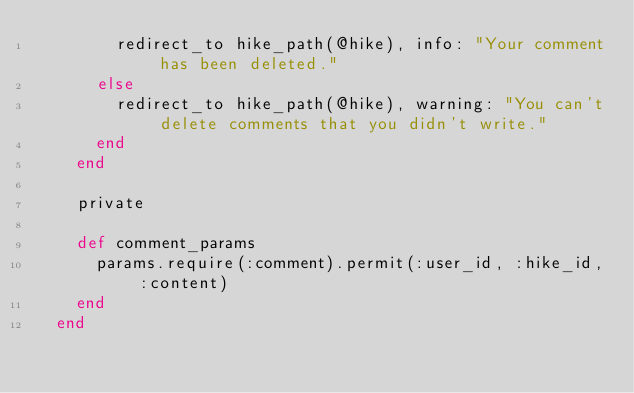<code> <loc_0><loc_0><loc_500><loc_500><_Ruby_>        redirect_to hike_path(@hike), info: "Your comment has been deleted."
      else
        redirect_to hike_path(@hike), warning: "You can't delete comments that you didn't write."
      end
    end
  
    private
  
    def comment_params
      params.require(:comment).permit(:user_id, :hike_id, :content)
    end
  end</code> 